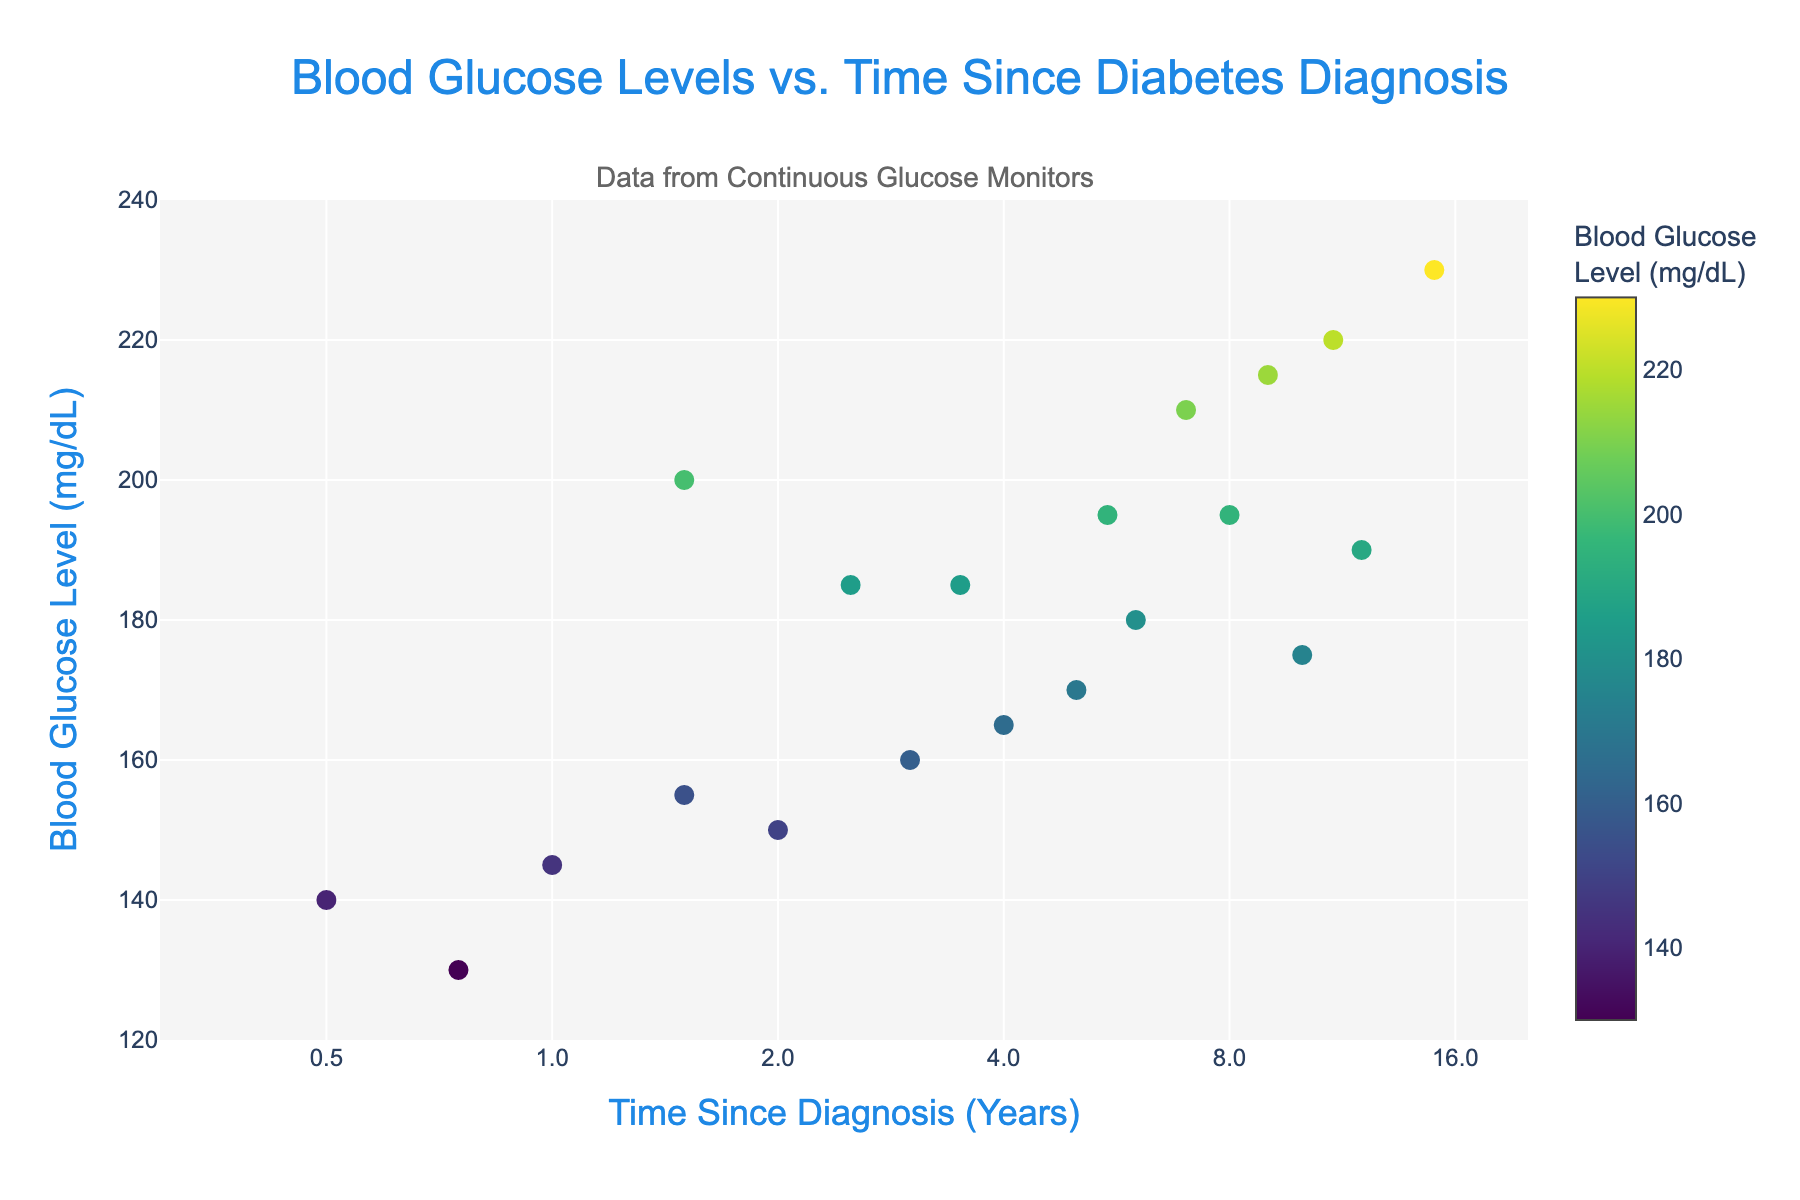How many years since the first patient's diabetes diagnosis? Look for the data point with the smallest x-axis value, which represents the shortest time since diagnosis, and check the x-coordinate (log axis). The smallest x-value is approximately 0.5 years (Patient P001).
Answer: 0.5 years What is the blood glucose level of the patient with the second highest time since diagnosis? Sort the data by time since diagnosis in descending order. The second highest time since diagnosis is 12 years (Patient P011). Check this data point's y-coordinate.
Answer: 190 mg/dL Which patient has the highest blood glucose level? Look at the y-axis and find the data point furthest up. The patient with the highest y-value (220 mg/dL) is P016.
Answer: P016 What is the difference in blood glucose levels between patients diagnosed 1 year and 5 years ago? Identify the y-values for the patients diagnosed 1 year (P002, y = 145 mg/dL) and 5 years (P007, y = 170 mg/dL) ago. Subtract the smaller y-value from the larger one.
Answer: 25 mg/dL What is the median blood glucose level for patients diagnosed less than 2 years ago? Filter the patients diagnosed for less than 2 years and list their blood glucose levels: (140, 145, 130, 155). Sort these values: (130, 140, 145, 155). The median of four values is the average of the two middle numbers: (140 + 145) / 2 = 142.5 mg/dL.
Answer: 142.5 mg/dL Are blood glucose levels generally higher for patients diagnosed longer ago? Observe the trend in the plot. Generally, as the x-axis (time since diagnosis) increases, the y-axis (blood glucose level) also tends to increase, suggesting higher levels for patients diagnosed longer ago.
Answer: Yes What is the average blood glucose level for all patients in the dataset? Sum all the y-values (blood glucose levels) and divide by the number of patients: (140 + 145 + 150 + 155 + 160 + 165 + 170 + 175 + 180 + 185 + 190 + 195 + 200 + 210 + 215 + 220 + 130 + 185 + 195 + 230) / 20 = 177.5 mg/dL.
Answer: 177.5 mg/dL Which patient has the lowest blood glucose level, and how many years since their diagnosis? Look for the data point with the smallest y-axis value (130 mg/dL) and identify the x-coordinate. Patient P017 has a glucose level of 130 mg/dL and a diagnosis of 0.75 years.
Answer: P017, 0.75 years What is the range of blood glucose levels observed in this plot? Identify the minimum and maximum y-values from the data. The minimum is 130 mg/dL (P017) and the maximum is 220 mg/dL (P016). The range is 220 - 130 = 90 mg/dL.
Answer: 90 mg/dL At roughly what time since diagnosis do blood glucose levels exceed 200 mg/dL? Observe the x-axis values where blood glucose levels (y-values) are at or above 200 mg/dL, which occurs around 1.5 years (P013, y = 200 mg/dL).
Answer: Around 1.5 years 